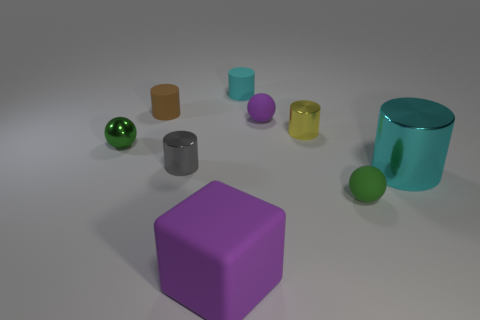How many objects are spheres behind the large metal thing or big cyan cylinders that are in front of the tiny cyan rubber thing?
Offer a terse response. 3. What number of other things are the same size as the gray metallic object?
Make the answer very short. 6. What is the shape of the metal thing that is behind the tiny green shiny sphere in front of the cyan rubber object?
Your answer should be very brief. Cylinder. Is the color of the cylinder behind the brown rubber cylinder the same as the large object that is right of the purple rubber ball?
Offer a very short reply. Yes. What color is the large metal object?
Your answer should be very brief. Cyan. Are there any brown cylinders?
Provide a short and direct response. Yes. Are there any small green objects right of the big purple cube?
Give a very brief answer. Yes. There is a yellow object that is the same shape as the brown thing; what is its material?
Provide a succinct answer. Metal. How many other things are the same shape as the yellow shiny object?
Make the answer very short. 4. There is a small cylinder on the right side of the small rubber cylinder on the right side of the rubber cube; what number of tiny green rubber balls are in front of it?
Offer a terse response. 1. 